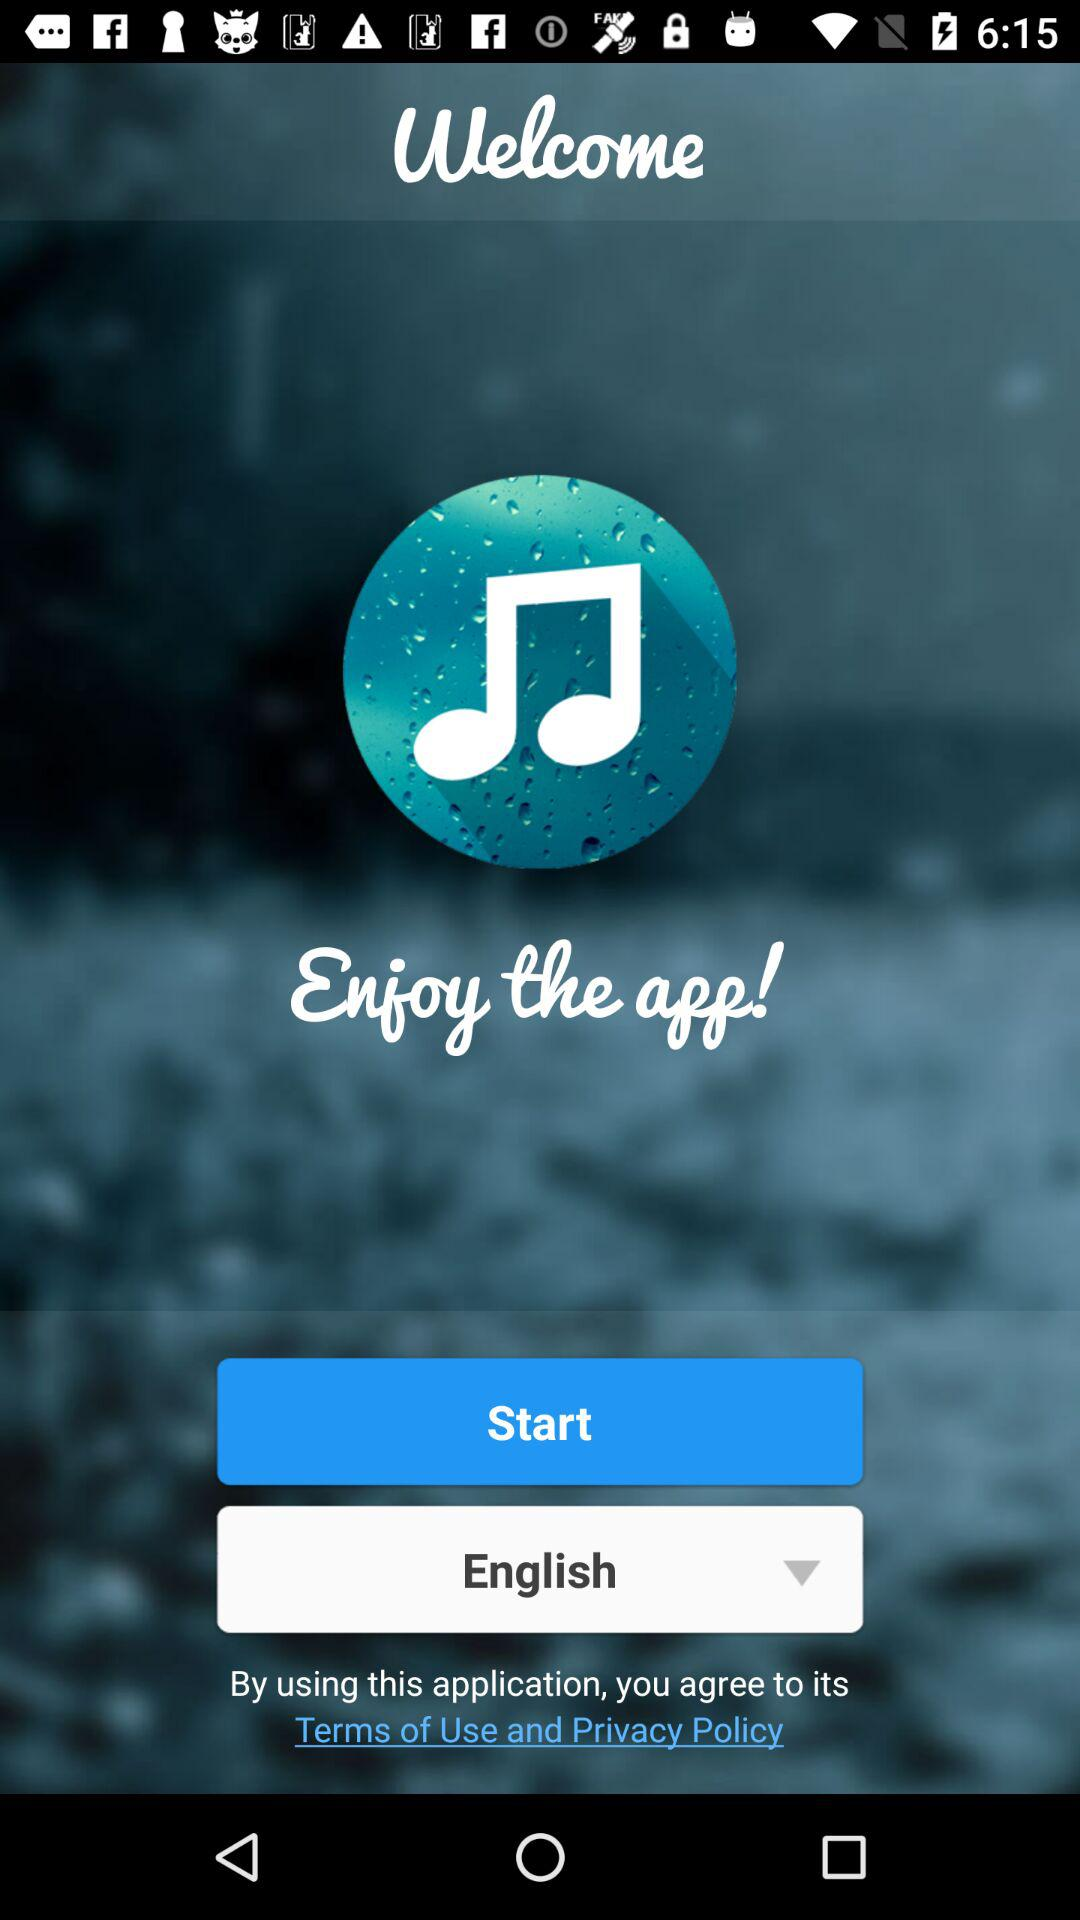What is the selected language? The selected language is "English". 